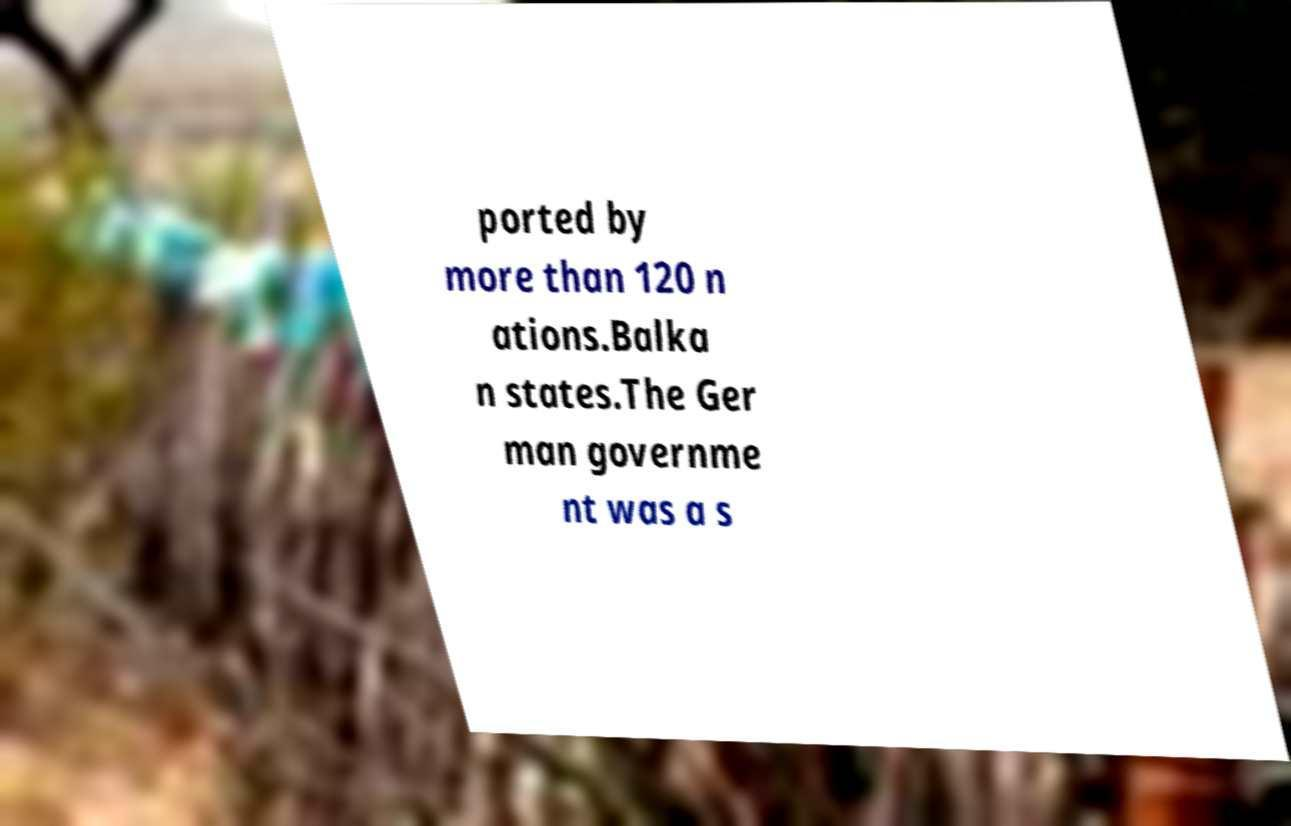For documentation purposes, I need the text within this image transcribed. Could you provide that? ported by more than 120 n ations.Balka n states.The Ger man governme nt was a s 